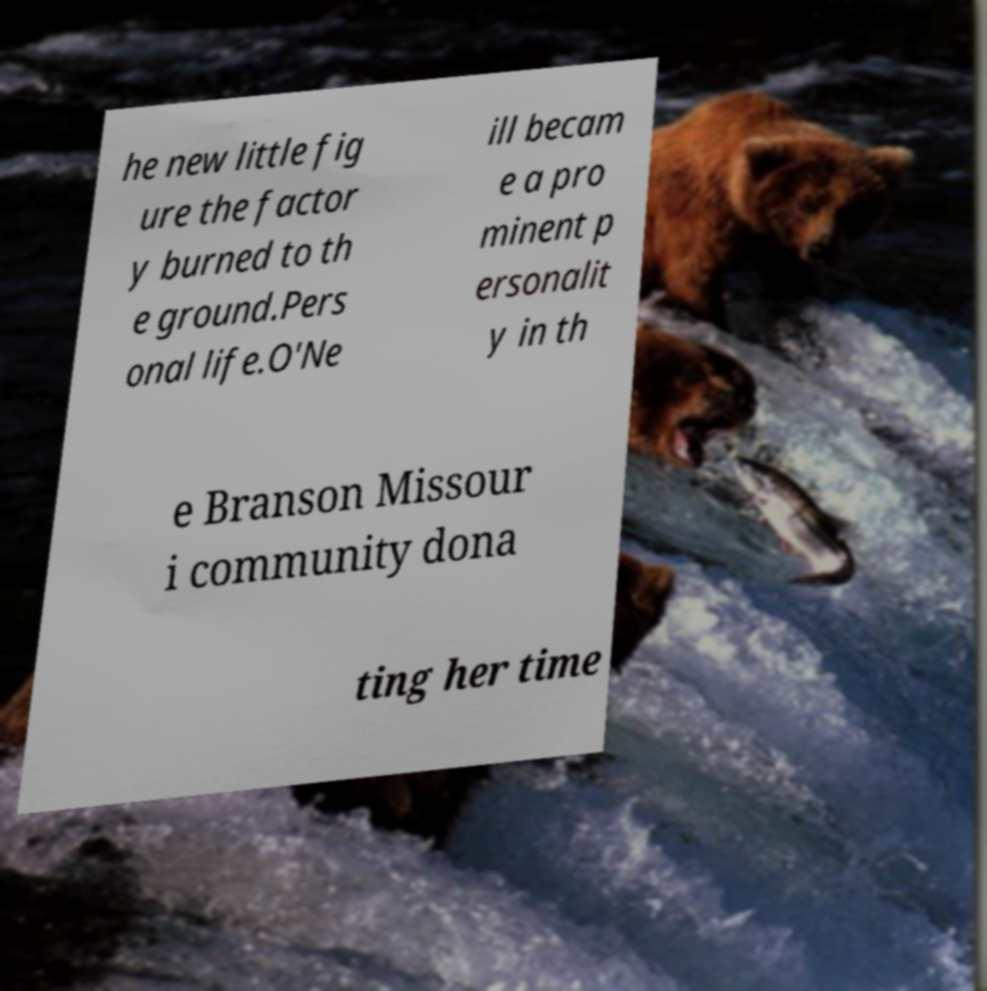I need the written content from this picture converted into text. Can you do that? he new little fig ure the factor y burned to th e ground.Pers onal life.O'Ne ill becam e a pro minent p ersonalit y in th e Branson Missour i community dona ting her time 